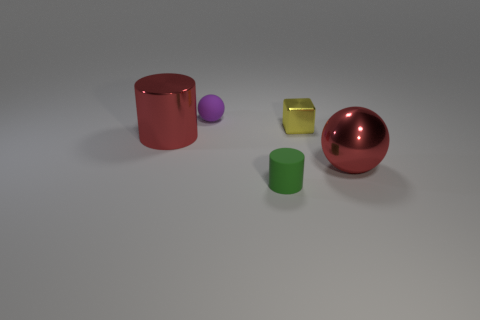Add 1 balls. How many objects exist? 6 Subtract all cubes. How many objects are left? 4 Subtract all tiny rubber things. Subtract all metal cubes. How many objects are left? 2 Add 1 small blocks. How many small blocks are left? 2 Add 1 yellow things. How many yellow things exist? 2 Subtract 0 gray cylinders. How many objects are left? 5 